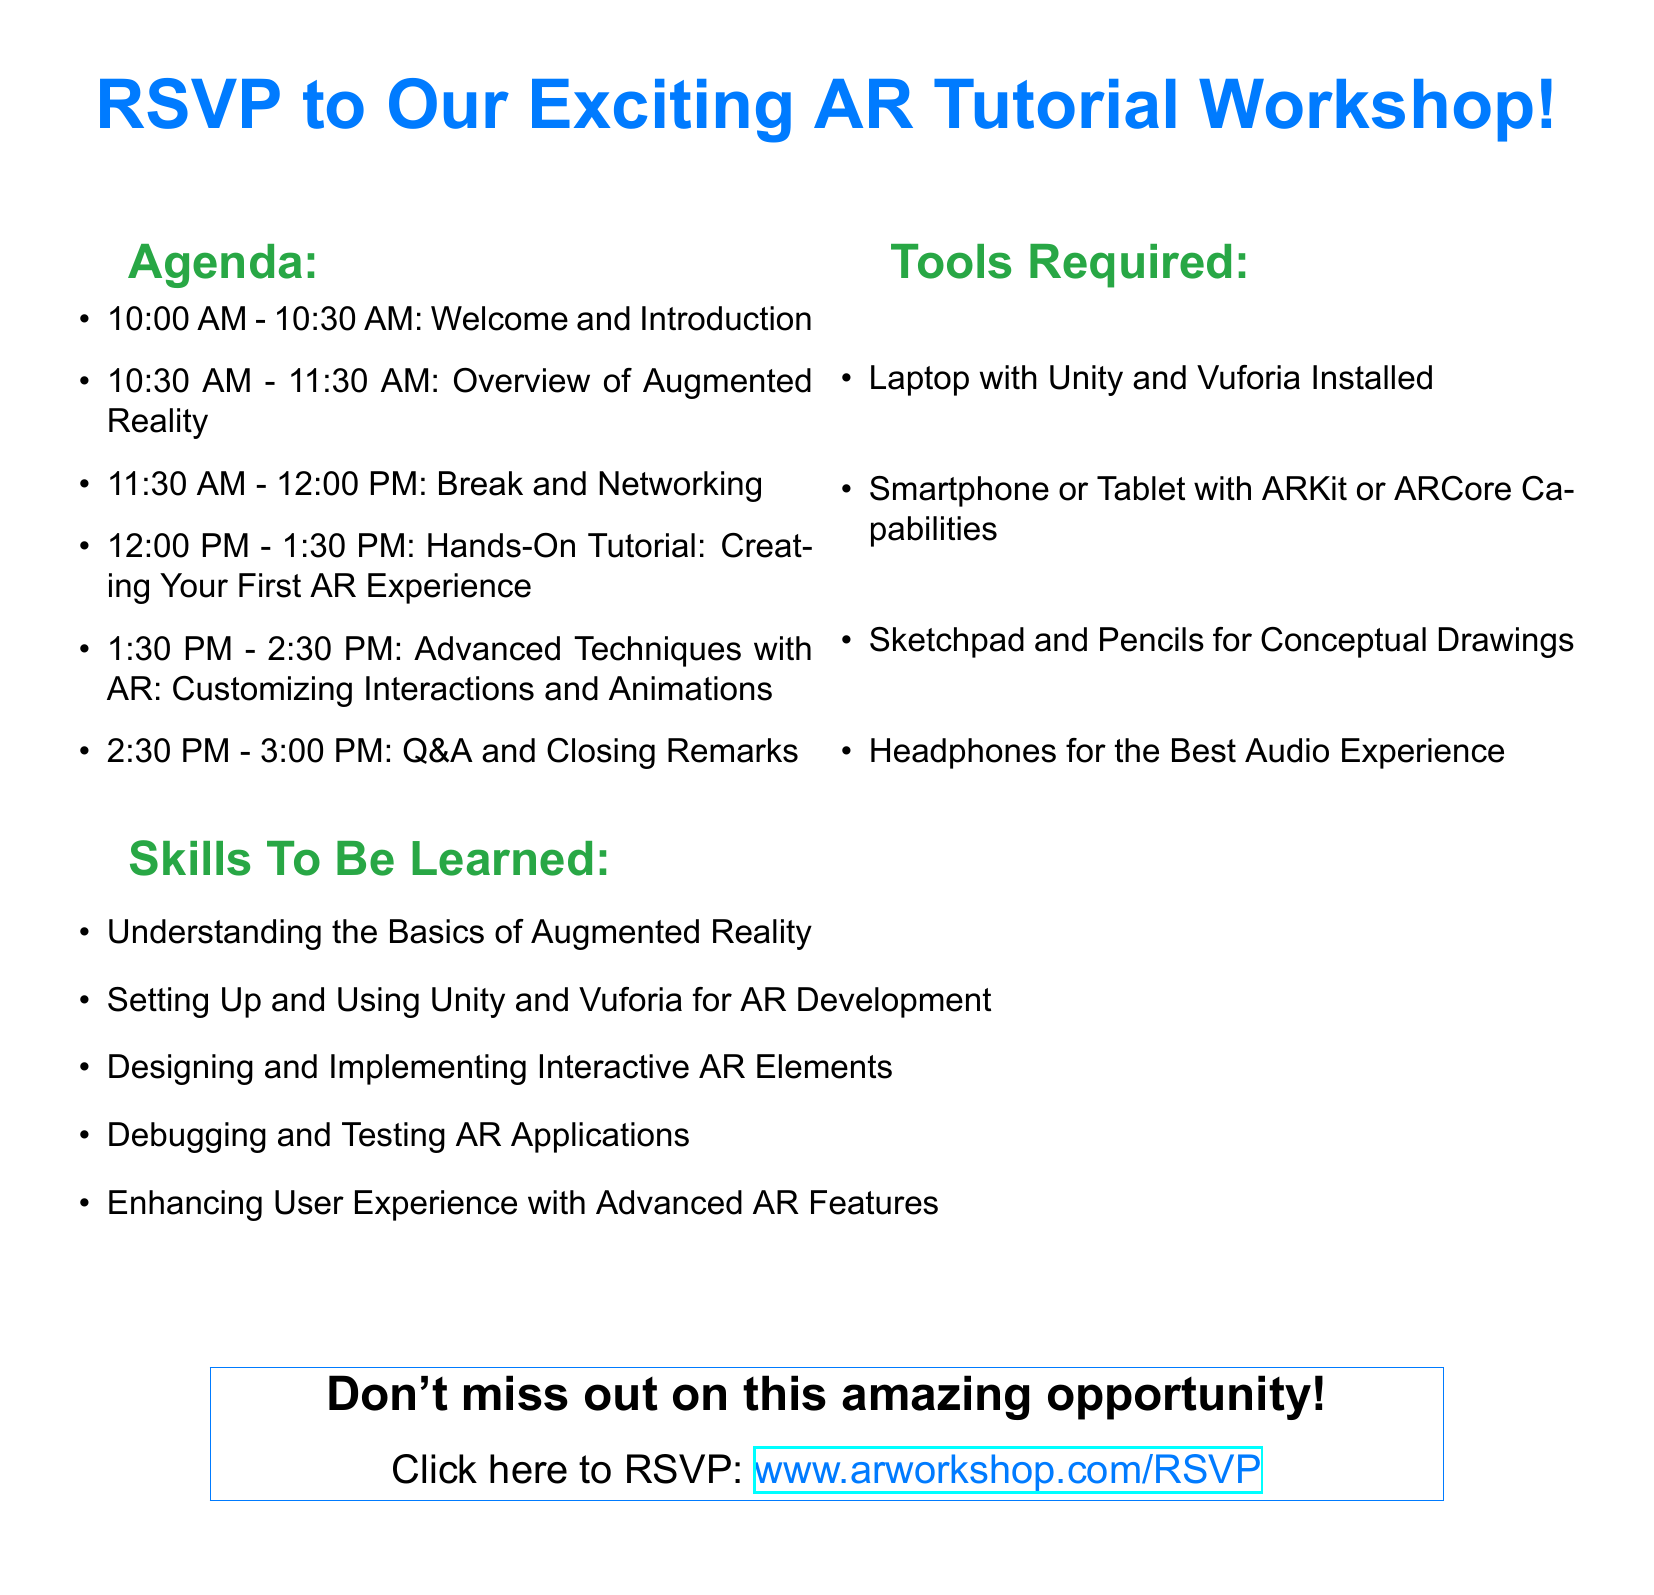What time does the workshop start? The workshop starts at 10:00 AM as mentioned in the agenda section of the document.
Answer: 10:00 AM How long is the break during the workshop? The break is scheduled from 11:30 AM to 12:00 PM, which is a total of 30 minutes.
Answer: 30 minutes What tool is required for AR development? The document specifies that Unity and Vuforia should be installed on the laptop for AR development.
Answer: Unity and Vuforia What skills will participants learn related to user experience? The participants will learn to enhance user experience with advanced AR features, as outlined in the skills section.
Answer: Enhancing User Experience What is the duration of the hands-on tutorial? The hands-on tutorial on creating an AR experience lasts from 12:00 PM to 1:30 PM, totaling 1 hour and 30 minutes.
Answer: 1 hour and 30 minutes How many sessions are scheduled before the Q&A? There are four sessions scheduled before the Q&A session, which includes the introduction, overview, break, and hands-on tutorial.
Answer: Four sessions What should participants bring for concept drawings? Participants are advised to bring a sketchpad and pencils for conceptual drawings as listed in the tools required.
Answer: Sketchpad and Pencils Is there a link to RSVP? The document provides a clickable link to RSVP, which is explicitly stated in the closing section.
Answer: www.arworkshop.com/RSVP 